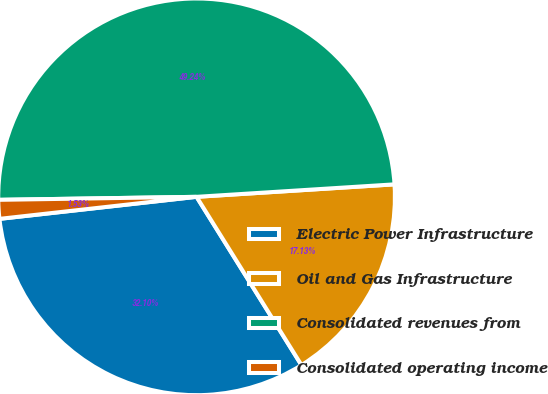Convert chart to OTSL. <chart><loc_0><loc_0><loc_500><loc_500><pie_chart><fcel>Electric Power Infrastructure<fcel>Oil and Gas Infrastructure<fcel>Consolidated revenues from<fcel>Consolidated operating income<nl><fcel>32.1%<fcel>17.13%<fcel>49.24%<fcel>1.53%<nl></chart> 